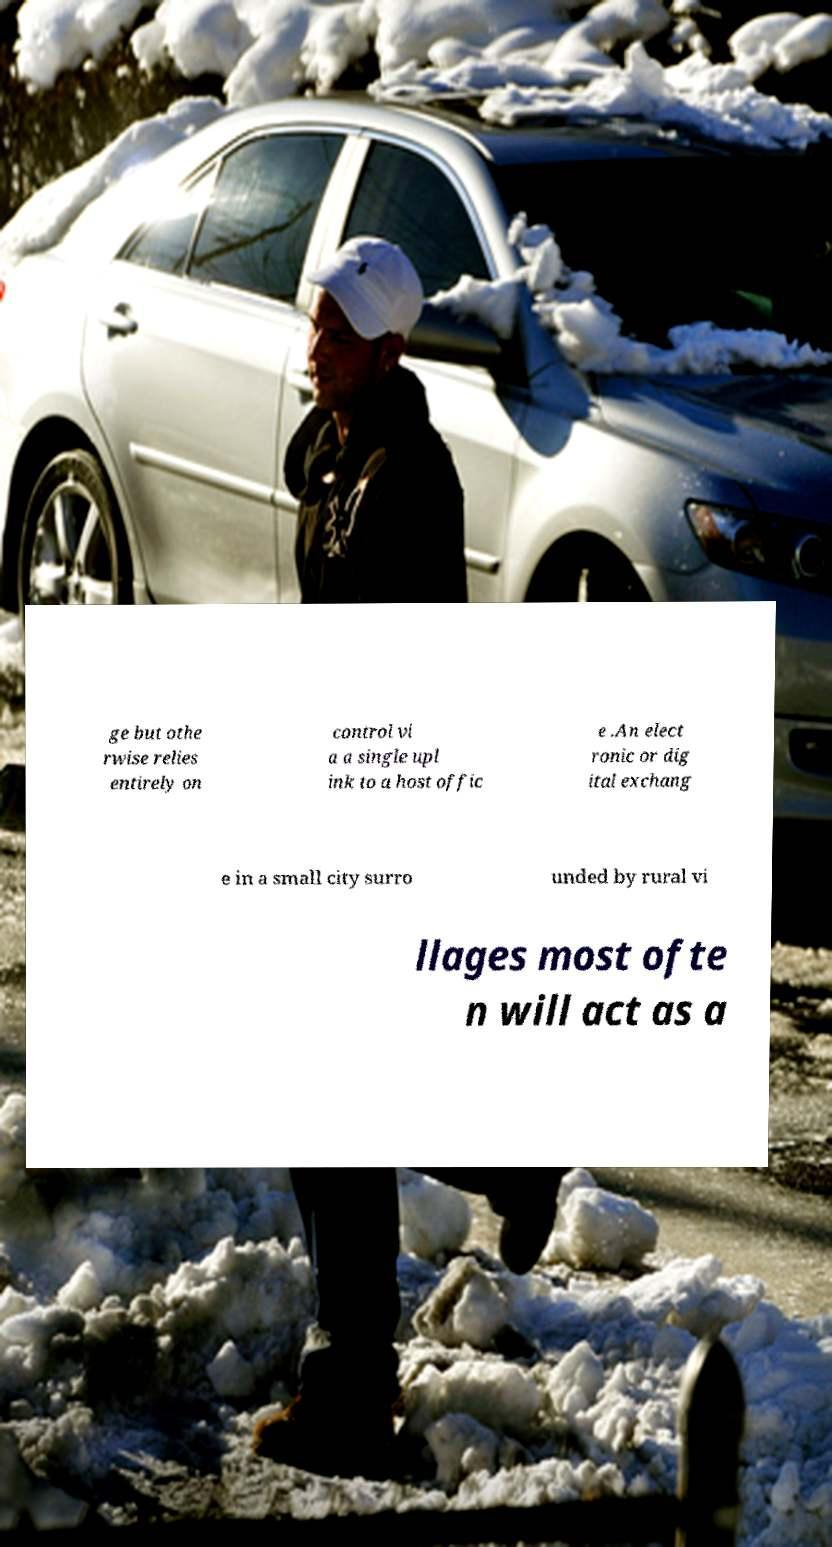Can you read and provide the text displayed in the image?This photo seems to have some interesting text. Can you extract and type it out for me? ge but othe rwise relies entirely on control vi a a single upl ink to a host offic e .An elect ronic or dig ital exchang e in a small city surro unded by rural vi llages most ofte n will act as a 